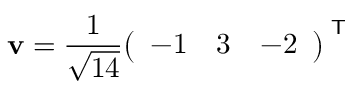Convert formula to latex. <formula><loc_0><loc_0><loc_500><loc_500>v = { \frac { 1 } { \sqrt { 1 4 } } } { \left ( \begin{array} { l l l } { - 1 } & { 3 } & { - 2 } \end{array} \right ) } ^ { T }</formula> 